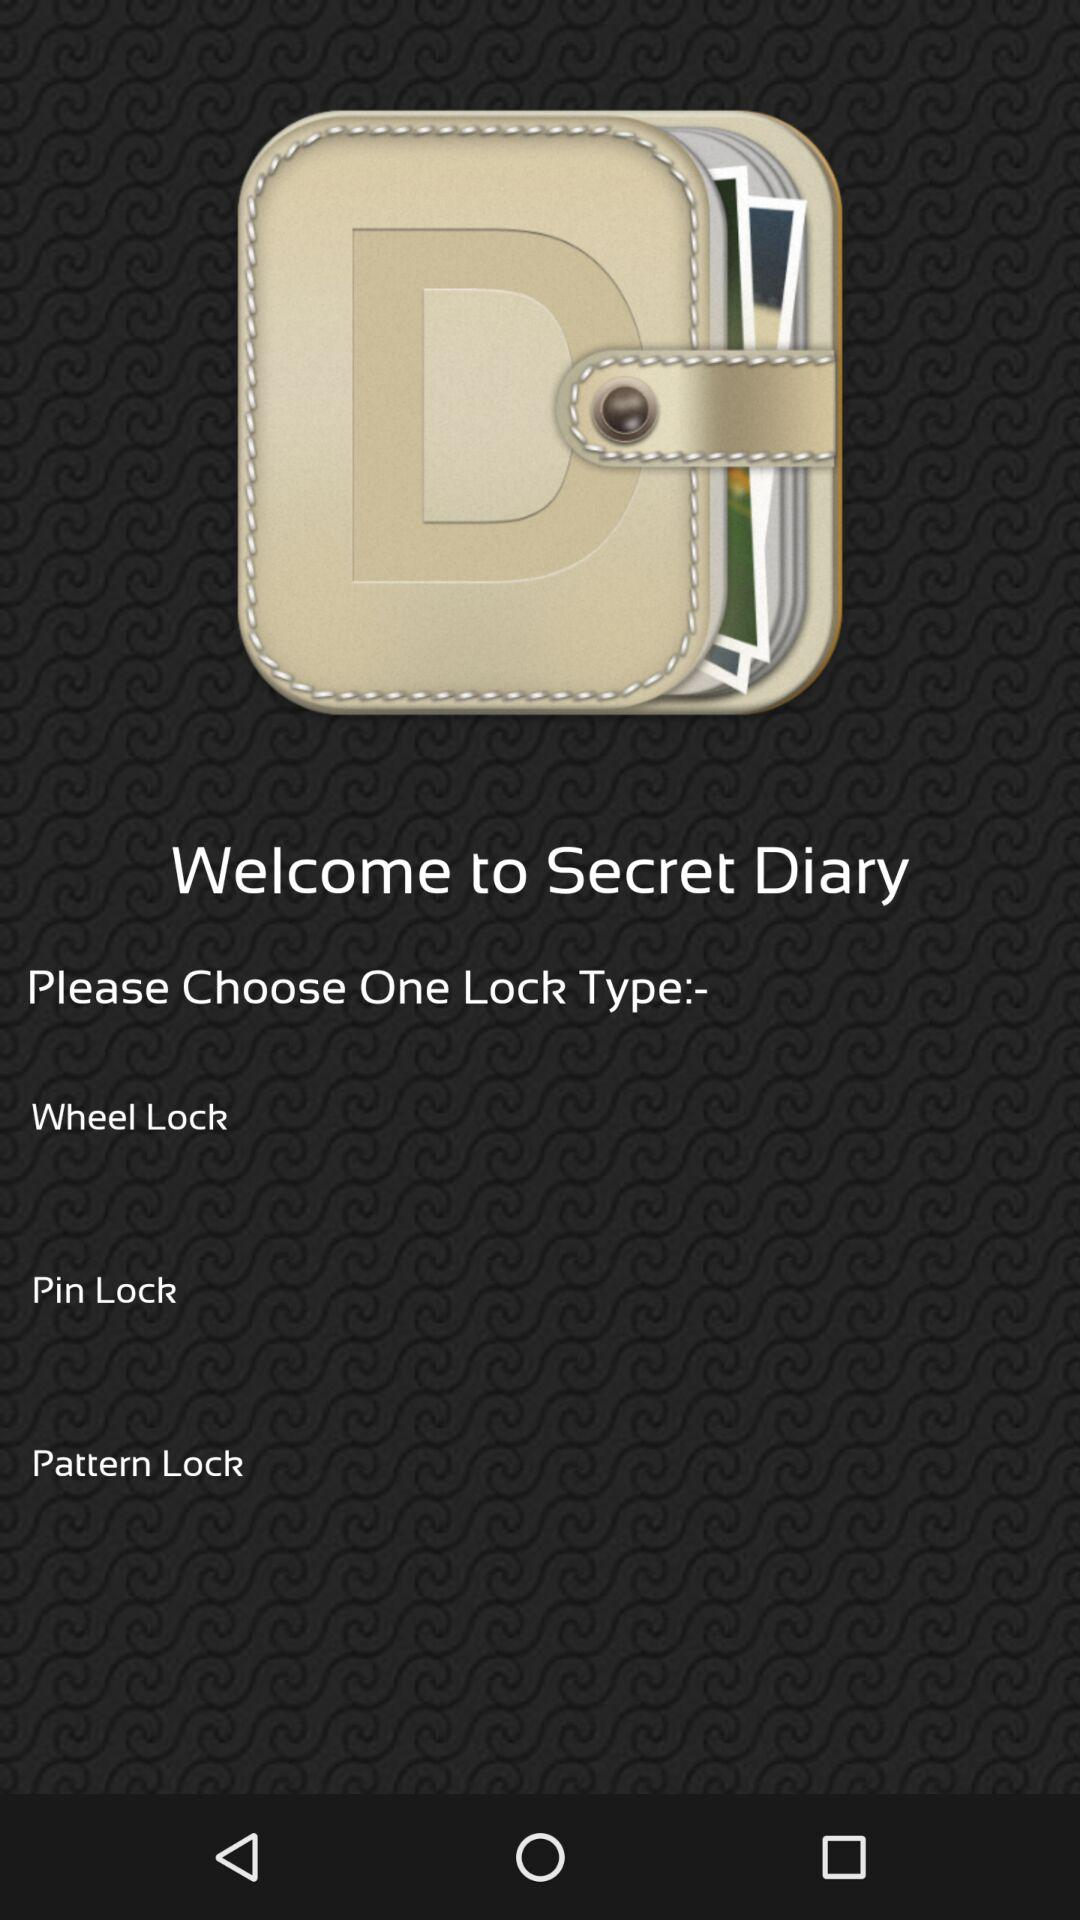Which different lock type options are given? The different lock type options are "Wheel Lock", "Pin Lock" and "Pattern Lock". 